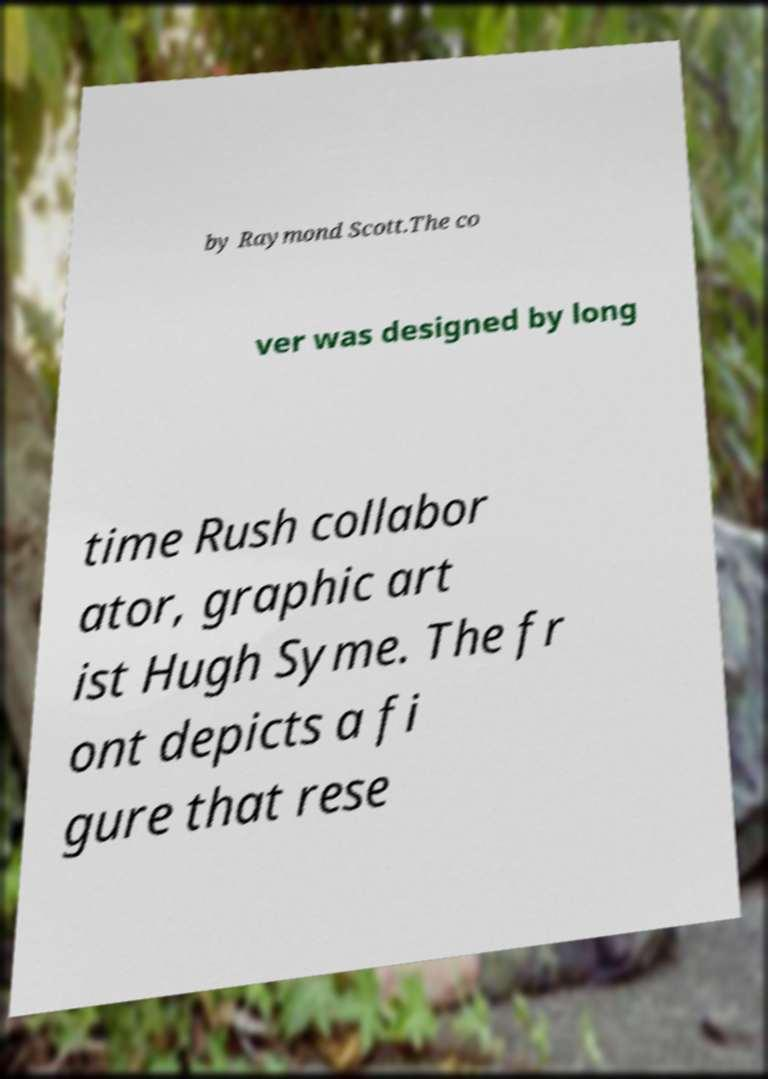Please identify and transcribe the text found in this image. by Raymond Scott.The co ver was designed by long time Rush collabor ator, graphic art ist Hugh Syme. The fr ont depicts a fi gure that rese 